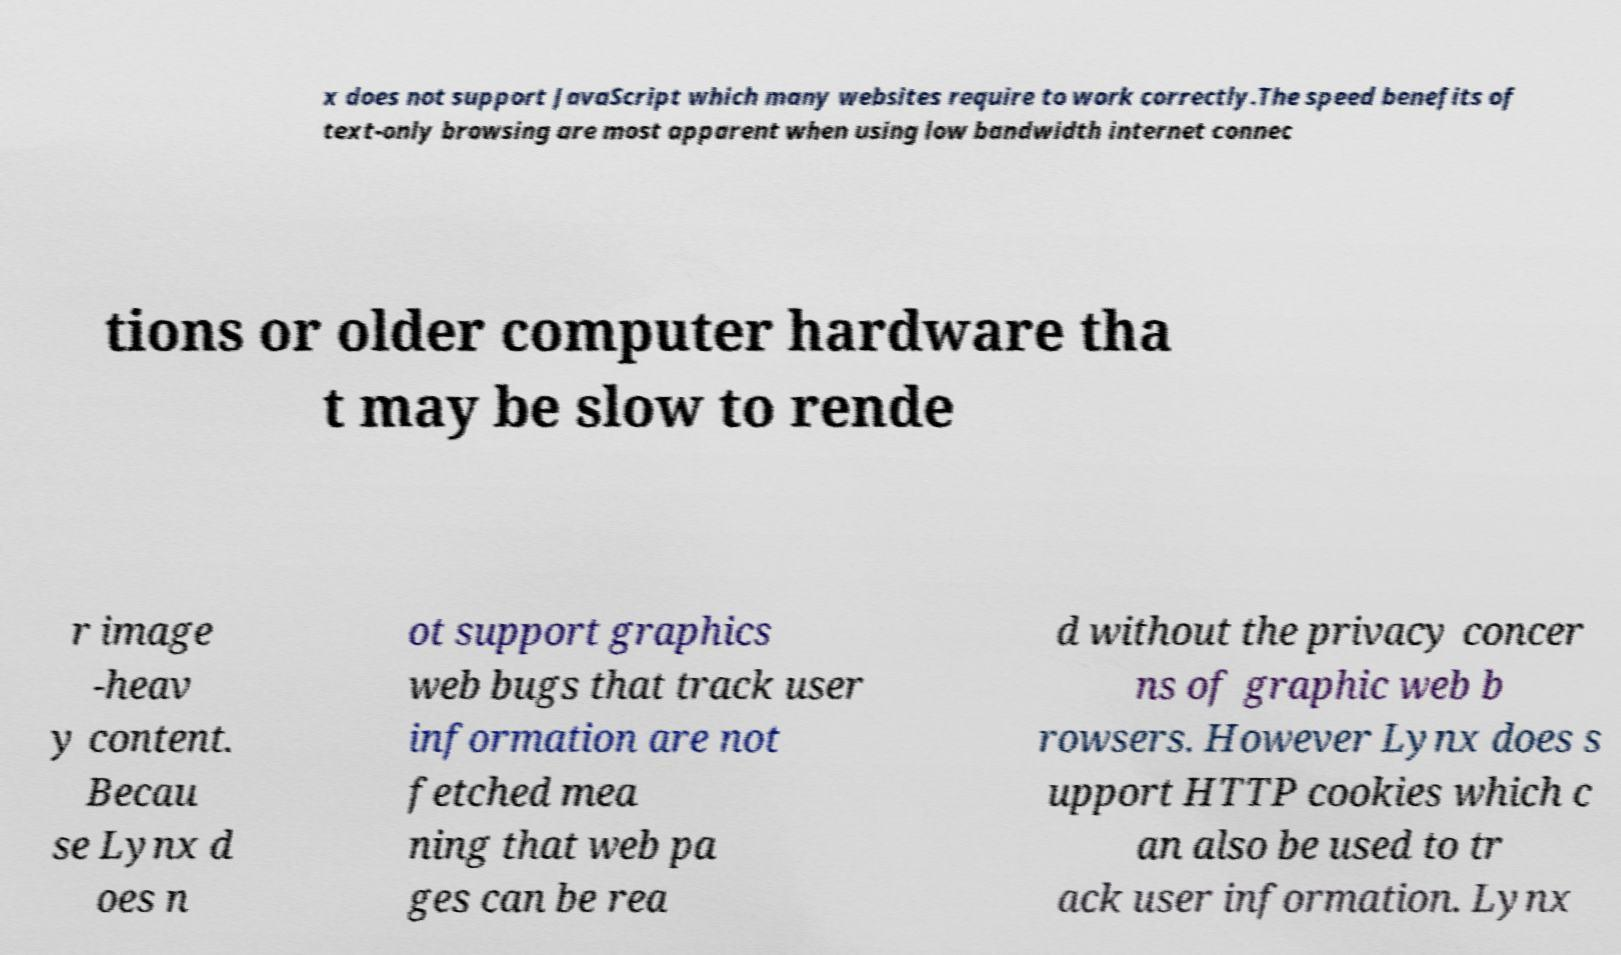Can you read and provide the text displayed in the image?This photo seems to have some interesting text. Can you extract and type it out for me? x does not support JavaScript which many websites require to work correctly.The speed benefits of text-only browsing are most apparent when using low bandwidth internet connec tions or older computer hardware tha t may be slow to rende r image -heav y content. Becau se Lynx d oes n ot support graphics web bugs that track user information are not fetched mea ning that web pa ges can be rea d without the privacy concer ns of graphic web b rowsers. However Lynx does s upport HTTP cookies which c an also be used to tr ack user information. Lynx 